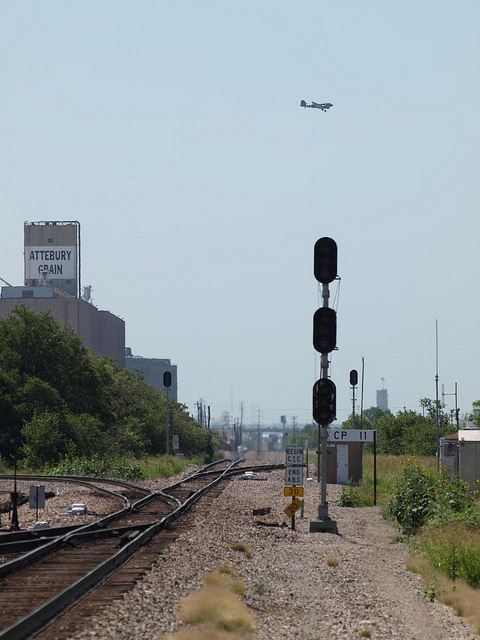Extract all visible text content from this image. ATTEBURY GRAIN CP 11 CIC 